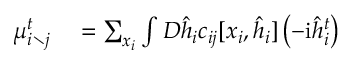Convert formula to latex. <formula><loc_0><loc_0><loc_500><loc_500>\begin{array} { r l } { \mu _ { i \ j } ^ { t } } & = \sum _ { x _ { i } } \int D \hat { h } _ { i } c _ { i j } [ x _ { i } , \hat { h } _ { i } ] \left ( - i \hat { h } _ { i } ^ { t } \right ) } \end{array}</formula> 